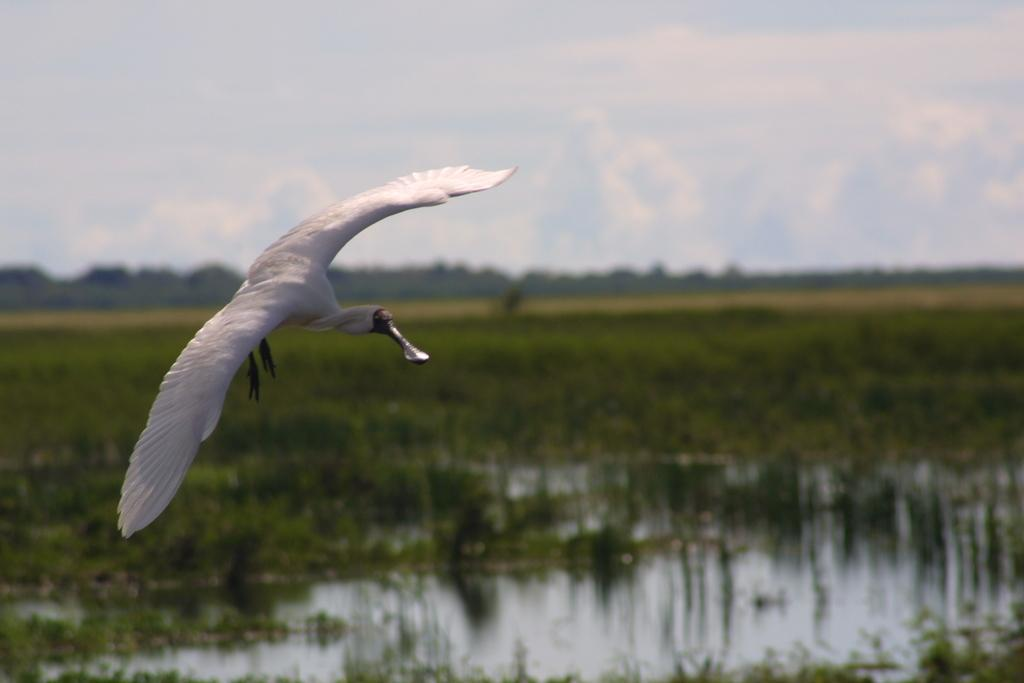What type of bird is in the image? There is an albatross in the image. What can be seen in the background of the image? There are trees, grass, water, and other objects visible in the background of the image. What is visible at the top of the image? The sky is visible at the top of the image. Who is the manager of the yard in the image? There is no mention of a yard or a manager in the image; it features an albatross and a background with trees, grass, water, and other objects. 